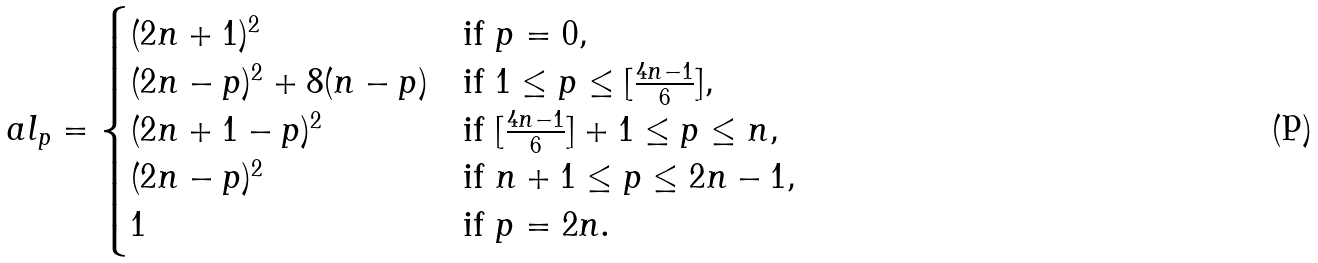Convert formula to latex. <formula><loc_0><loc_0><loc_500><loc_500>\ a l _ { p } = \begin{cases} ( 2 n + 1 ) ^ { 2 } & \text {if } p = 0 , \\ ( 2 n - p ) ^ { 2 } + 8 ( n - p ) & \text {if } 1 \leq p \leq [ \frac { 4 n - 1 } { 6 } ] , \\ ( 2 n + 1 - p ) ^ { 2 } & \text {if } [ \frac { 4 n - 1 } { 6 } ] + 1 \leq p \leq n , \\ ( 2 n - p ) ^ { 2 } & \text {if } n + 1 \leq p \leq 2 n - 1 , \\ 1 & \text {if } p = 2 n . \end{cases}</formula> 